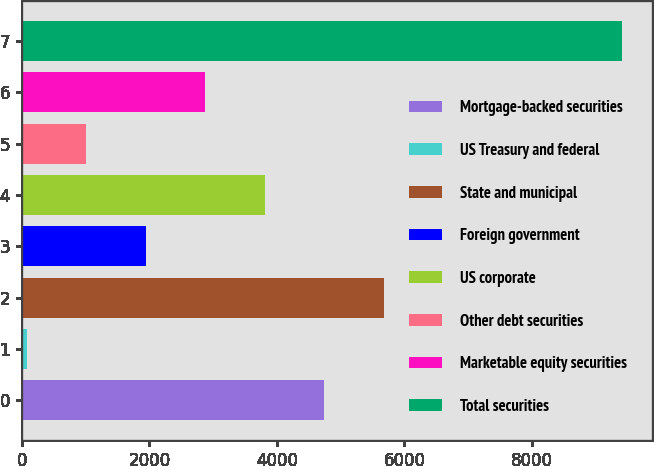<chart> <loc_0><loc_0><loc_500><loc_500><bar_chart><fcel>Mortgage-backed securities<fcel>US Treasury and federal<fcel>State and municipal<fcel>Foreign government<fcel>US corporate<fcel>Other debt securities<fcel>Marketable equity securities<fcel>Total securities<nl><fcel>4745.5<fcel>77<fcel>5679.2<fcel>1944.4<fcel>3811.8<fcel>1010.7<fcel>2878.1<fcel>9414<nl></chart> 